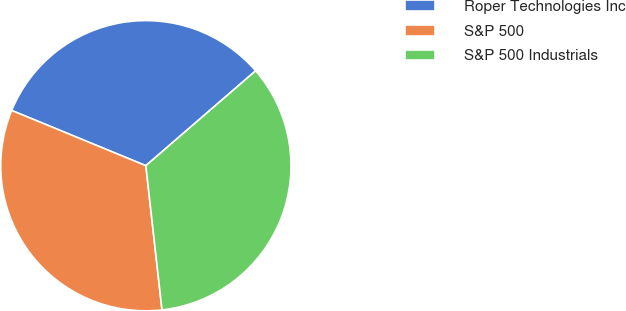Convert chart to OTSL. <chart><loc_0><loc_0><loc_500><loc_500><pie_chart><fcel>Roper Technologies Inc<fcel>S&P 500<fcel>S&P 500 Industrials<nl><fcel>32.44%<fcel>32.99%<fcel>34.57%<nl></chart> 